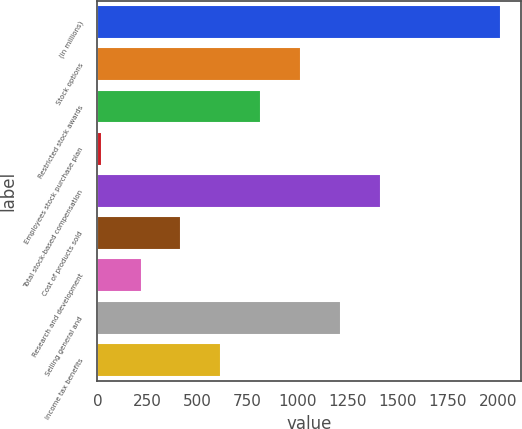<chart> <loc_0><loc_0><loc_500><loc_500><bar_chart><fcel>(in millions)<fcel>Stock options<fcel>Restricted stock awards<fcel>Employees stock purchase plan<fcel>Total stock-based compensation<fcel>Cost of products sold<fcel>Research and development<fcel>Selling general and<fcel>Income tax benefits<nl><fcel>2016<fcel>1018.5<fcel>819<fcel>21<fcel>1417.5<fcel>420<fcel>220.5<fcel>1218<fcel>619.5<nl></chart> 